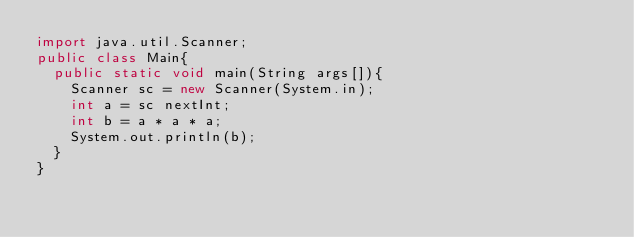Convert code to text. <code><loc_0><loc_0><loc_500><loc_500><_Java_>import java.util.Scanner;
public class Main{
  public static void main(String args[]){
    Scanner sc = new Scanner(System.in);
    int a = sc nextInt;
    int b = a * a * a;
    System.out.println(b);
  }
}</code> 